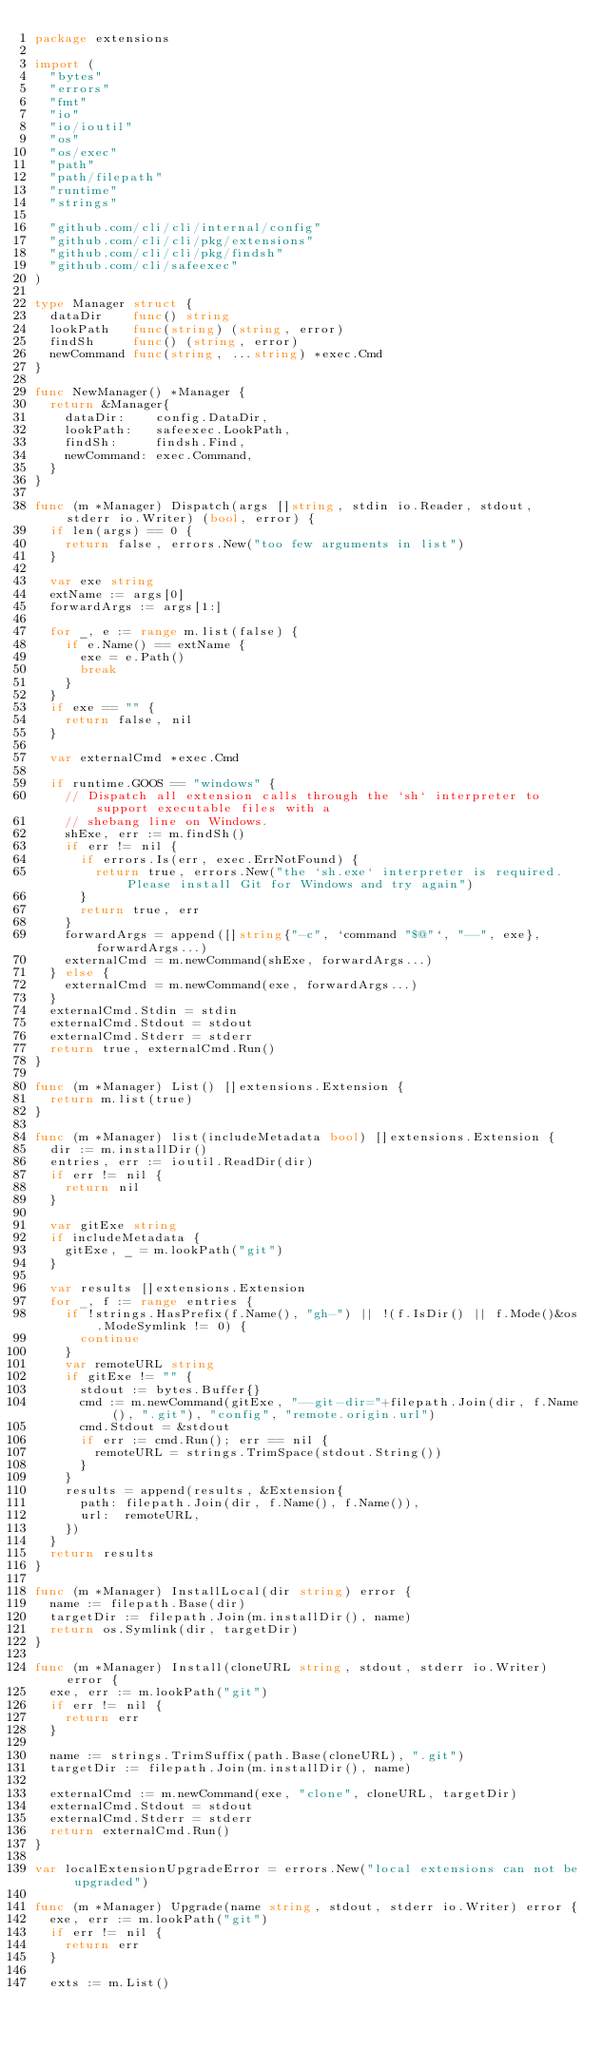<code> <loc_0><loc_0><loc_500><loc_500><_Go_>package extensions

import (
	"bytes"
	"errors"
	"fmt"
	"io"
	"io/ioutil"
	"os"
	"os/exec"
	"path"
	"path/filepath"
	"runtime"
	"strings"

	"github.com/cli/cli/internal/config"
	"github.com/cli/cli/pkg/extensions"
	"github.com/cli/cli/pkg/findsh"
	"github.com/cli/safeexec"
)

type Manager struct {
	dataDir    func() string
	lookPath   func(string) (string, error)
	findSh     func() (string, error)
	newCommand func(string, ...string) *exec.Cmd
}

func NewManager() *Manager {
	return &Manager{
		dataDir:    config.DataDir,
		lookPath:   safeexec.LookPath,
		findSh:     findsh.Find,
		newCommand: exec.Command,
	}
}

func (m *Manager) Dispatch(args []string, stdin io.Reader, stdout, stderr io.Writer) (bool, error) {
	if len(args) == 0 {
		return false, errors.New("too few arguments in list")
	}

	var exe string
	extName := args[0]
	forwardArgs := args[1:]

	for _, e := range m.list(false) {
		if e.Name() == extName {
			exe = e.Path()
			break
		}
	}
	if exe == "" {
		return false, nil
	}

	var externalCmd *exec.Cmd

	if runtime.GOOS == "windows" {
		// Dispatch all extension calls through the `sh` interpreter to support executable files with a
		// shebang line on Windows.
		shExe, err := m.findSh()
		if err != nil {
			if errors.Is(err, exec.ErrNotFound) {
				return true, errors.New("the `sh.exe` interpreter is required. Please install Git for Windows and try again")
			}
			return true, err
		}
		forwardArgs = append([]string{"-c", `command "$@"`, "--", exe}, forwardArgs...)
		externalCmd = m.newCommand(shExe, forwardArgs...)
	} else {
		externalCmd = m.newCommand(exe, forwardArgs...)
	}
	externalCmd.Stdin = stdin
	externalCmd.Stdout = stdout
	externalCmd.Stderr = stderr
	return true, externalCmd.Run()
}

func (m *Manager) List() []extensions.Extension {
	return m.list(true)
}

func (m *Manager) list(includeMetadata bool) []extensions.Extension {
	dir := m.installDir()
	entries, err := ioutil.ReadDir(dir)
	if err != nil {
		return nil
	}

	var gitExe string
	if includeMetadata {
		gitExe, _ = m.lookPath("git")
	}

	var results []extensions.Extension
	for _, f := range entries {
		if !strings.HasPrefix(f.Name(), "gh-") || !(f.IsDir() || f.Mode()&os.ModeSymlink != 0) {
			continue
		}
		var remoteURL string
		if gitExe != "" {
			stdout := bytes.Buffer{}
			cmd := m.newCommand(gitExe, "--git-dir="+filepath.Join(dir, f.Name(), ".git"), "config", "remote.origin.url")
			cmd.Stdout = &stdout
			if err := cmd.Run(); err == nil {
				remoteURL = strings.TrimSpace(stdout.String())
			}
		}
		results = append(results, &Extension{
			path: filepath.Join(dir, f.Name(), f.Name()),
			url:  remoteURL,
		})
	}
	return results
}

func (m *Manager) InstallLocal(dir string) error {
	name := filepath.Base(dir)
	targetDir := filepath.Join(m.installDir(), name)
	return os.Symlink(dir, targetDir)
}

func (m *Manager) Install(cloneURL string, stdout, stderr io.Writer) error {
	exe, err := m.lookPath("git")
	if err != nil {
		return err
	}

	name := strings.TrimSuffix(path.Base(cloneURL), ".git")
	targetDir := filepath.Join(m.installDir(), name)

	externalCmd := m.newCommand(exe, "clone", cloneURL, targetDir)
	externalCmd.Stdout = stdout
	externalCmd.Stderr = stderr
	return externalCmd.Run()
}

var localExtensionUpgradeError = errors.New("local extensions can not be upgraded")

func (m *Manager) Upgrade(name string, stdout, stderr io.Writer) error {
	exe, err := m.lookPath("git")
	if err != nil {
		return err
	}

	exts := m.List()</code> 